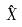Convert formula to latex. <formula><loc_0><loc_0><loc_500><loc_500>\hat { X }</formula> 